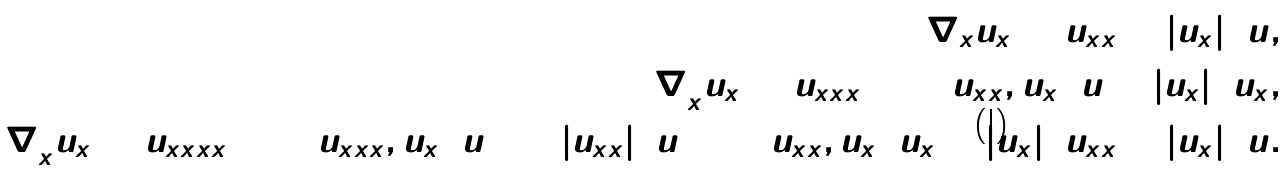<formula> <loc_0><loc_0><loc_500><loc_500>\nabla _ { x } u _ { x } = u _ { x x } + \left | u _ { x } \right | ^ { 2 } u , \\ \nabla _ { x } ^ { 2 } u _ { x } = u _ { x x x } + 3 \left ( u _ { x x } , u _ { x } \right ) u + \left | u _ { x } \right | ^ { 2 } u _ { x } , \\ \nabla _ { x } ^ { 3 } u _ { x } = u _ { x x x x } + 4 \left ( u _ { x x x } , u _ { x } \right ) u + 3 \left | u _ { x x } \right | ^ { 2 } u + 5 \left ( u _ { x x } , u _ { x } \right ) u _ { x } + \left | u _ { x } \right | ^ { 2 } u _ { x x } + \left | u _ { x } \right | ^ { 4 } u .</formula> 